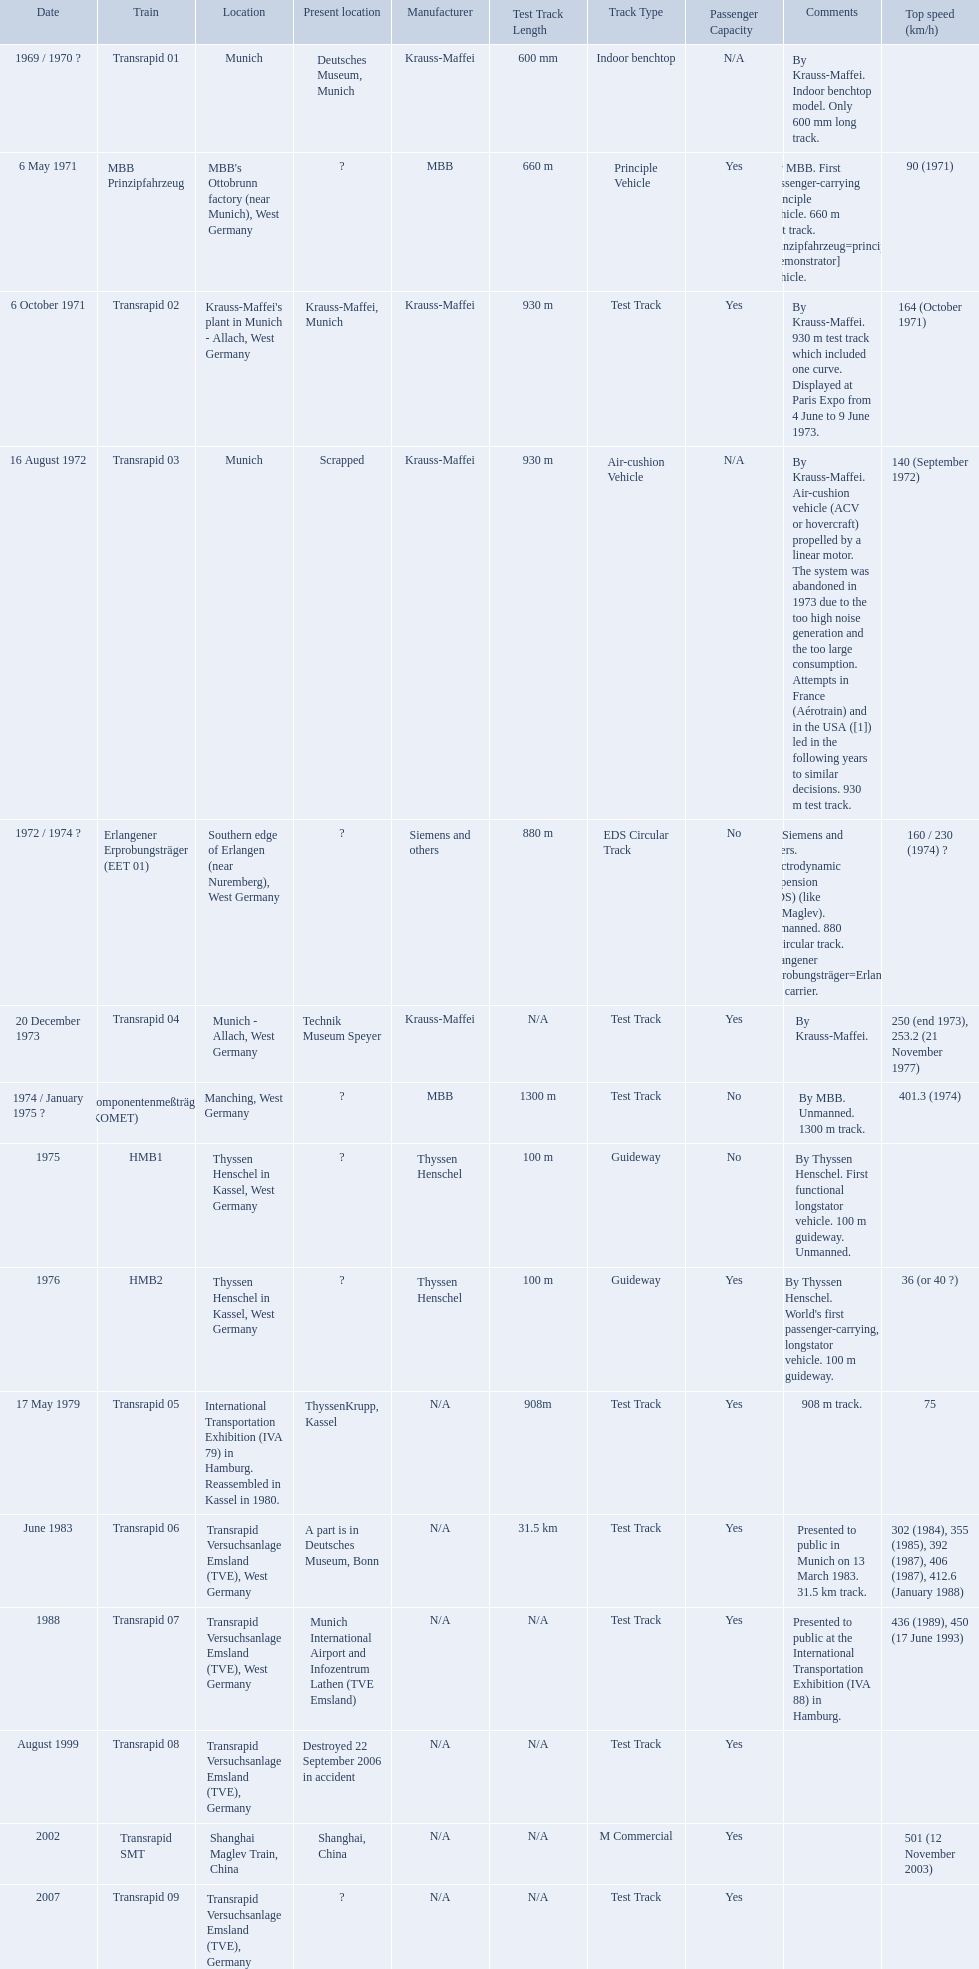What is the top speed reached by any trains shown here? 501 (12 November 2003). What train has reached a top speed of 501? Transrapid SMT. Which trains exceeded a top speed of 400+? Komponentenmeßträger (KOMET), Transrapid 07, Transrapid SMT. How about 500+? Transrapid SMT. 